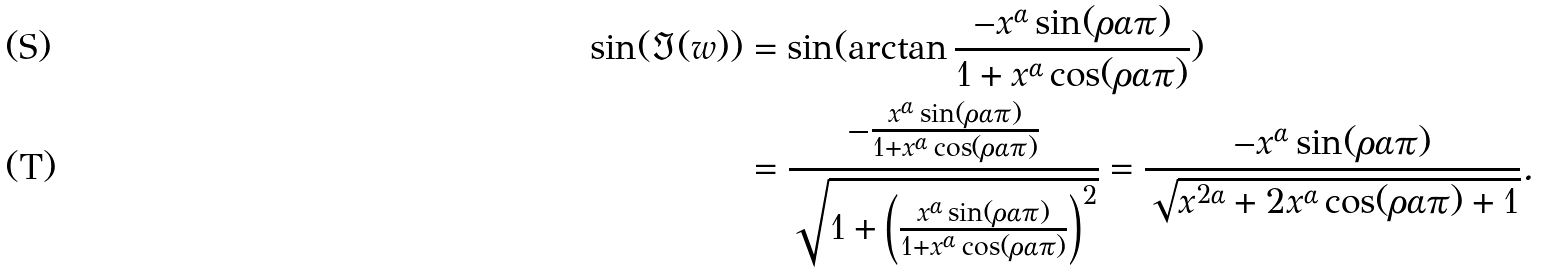Convert formula to latex. <formula><loc_0><loc_0><loc_500><loc_500>\sin ( \Im ( w ) ) & = \sin ( \arctan \frac { - x ^ { \alpha } \sin ( \rho \alpha \pi ) } { 1 + x ^ { \alpha } \cos ( \rho \alpha \pi ) } ) \\ & = \frac { - \frac { x ^ { \alpha } \sin ( \rho \alpha \pi ) } { 1 + x ^ { \alpha } \cos ( \rho \alpha \pi ) } } { \sqrt { 1 + \left ( \frac { x ^ { \alpha } \sin ( \rho \alpha \pi ) } { 1 + x ^ { \alpha } \cos ( \rho \alpha \pi ) } \right ) ^ { 2 } } } = \frac { - x ^ { \alpha } \sin ( \rho \alpha \pi ) } { \sqrt { x ^ { 2 \alpha } + 2 x ^ { \alpha } \cos ( \rho \alpha \pi ) + 1 } } .</formula> 